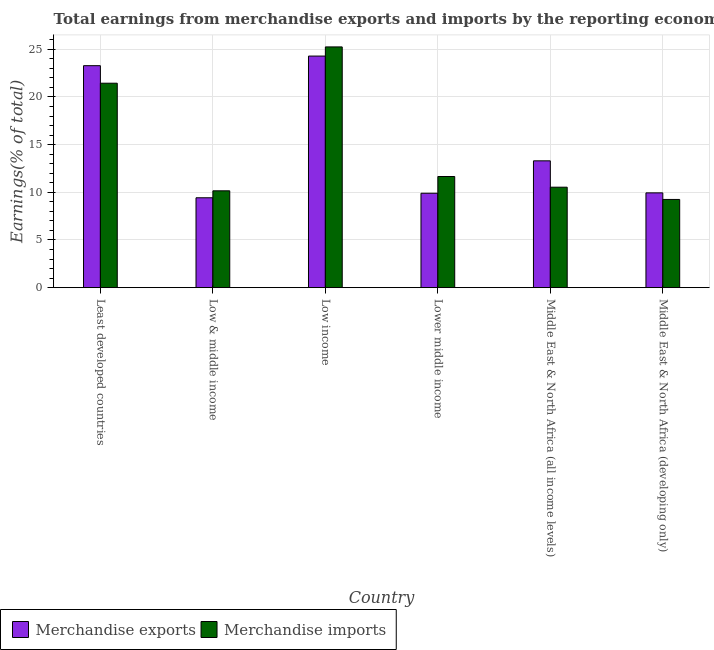Are the number of bars per tick equal to the number of legend labels?
Offer a terse response. Yes. How many bars are there on the 5th tick from the right?
Your answer should be very brief. 2. What is the label of the 1st group of bars from the left?
Make the answer very short. Least developed countries. In how many cases, is the number of bars for a given country not equal to the number of legend labels?
Your answer should be very brief. 0. What is the earnings from merchandise imports in Least developed countries?
Give a very brief answer. 21.44. Across all countries, what is the maximum earnings from merchandise imports?
Provide a short and direct response. 25.25. Across all countries, what is the minimum earnings from merchandise exports?
Your answer should be very brief. 9.43. In which country was the earnings from merchandise exports maximum?
Provide a short and direct response. Low income. What is the total earnings from merchandise exports in the graph?
Provide a short and direct response. 90.14. What is the difference between the earnings from merchandise imports in Lower middle income and that in Middle East & North Africa (developing only)?
Provide a succinct answer. 2.41. What is the difference between the earnings from merchandise exports in Middle East & North Africa (developing only) and the earnings from merchandise imports in Middle East & North Africa (all income levels)?
Keep it short and to the point. -0.6. What is the average earnings from merchandise exports per country?
Provide a succinct answer. 15.02. What is the difference between the earnings from merchandise imports and earnings from merchandise exports in Low & middle income?
Your answer should be compact. 0.73. In how many countries, is the earnings from merchandise imports greater than 21 %?
Provide a succinct answer. 2. What is the ratio of the earnings from merchandise exports in Low & middle income to that in Low income?
Offer a very short reply. 0.39. Is the difference between the earnings from merchandise exports in Low & middle income and Middle East & North Africa (all income levels) greater than the difference between the earnings from merchandise imports in Low & middle income and Middle East & North Africa (all income levels)?
Offer a very short reply. No. What is the difference between the highest and the second highest earnings from merchandise imports?
Ensure brevity in your answer.  3.81. What is the difference between the highest and the lowest earnings from merchandise imports?
Your answer should be very brief. 16. Is the sum of the earnings from merchandise imports in Lower middle income and Middle East & North Africa (all income levels) greater than the maximum earnings from merchandise exports across all countries?
Offer a very short reply. No. How many bars are there?
Your answer should be compact. 12. Are all the bars in the graph horizontal?
Provide a succinct answer. No. Are the values on the major ticks of Y-axis written in scientific E-notation?
Your response must be concise. No. What is the title of the graph?
Ensure brevity in your answer.  Total earnings from merchandise exports and imports by the reporting economy(residual) in 1985. What is the label or title of the Y-axis?
Your answer should be very brief. Earnings(% of total). What is the Earnings(% of total) of Merchandise exports in Least developed countries?
Ensure brevity in your answer.  23.28. What is the Earnings(% of total) of Merchandise imports in Least developed countries?
Make the answer very short. 21.44. What is the Earnings(% of total) in Merchandise exports in Low & middle income?
Your answer should be compact. 9.43. What is the Earnings(% of total) of Merchandise imports in Low & middle income?
Your answer should be compact. 10.16. What is the Earnings(% of total) of Merchandise exports in Low income?
Give a very brief answer. 24.29. What is the Earnings(% of total) in Merchandise imports in Low income?
Offer a terse response. 25.25. What is the Earnings(% of total) of Merchandise exports in Lower middle income?
Keep it short and to the point. 9.9. What is the Earnings(% of total) in Merchandise imports in Lower middle income?
Your response must be concise. 11.66. What is the Earnings(% of total) in Merchandise exports in Middle East & North Africa (all income levels)?
Your answer should be very brief. 13.3. What is the Earnings(% of total) in Merchandise imports in Middle East & North Africa (all income levels)?
Your response must be concise. 10.54. What is the Earnings(% of total) in Merchandise exports in Middle East & North Africa (developing only)?
Make the answer very short. 9.94. What is the Earnings(% of total) in Merchandise imports in Middle East & North Africa (developing only)?
Offer a very short reply. 9.25. Across all countries, what is the maximum Earnings(% of total) in Merchandise exports?
Your answer should be compact. 24.29. Across all countries, what is the maximum Earnings(% of total) of Merchandise imports?
Provide a short and direct response. 25.25. Across all countries, what is the minimum Earnings(% of total) of Merchandise exports?
Provide a succinct answer. 9.43. Across all countries, what is the minimum Earnings(% of total) of Merchandise imports?
Your answer should be very brief. 9.25. What is the total Earnings(% of total) of Merchandise exports in the graph?
Make the answer very short. 90.14. What is the total Earnings(% of total) in Merchandise imports in the graph?
Make the answer very short. 88.29. What is the difference between the Earnings(% of total) in Merchandise exports in Least developed countries and that in Low & middle income?
Ensure brevity in your answer.  13.85. What is the difference between the Earnings(% of total) of Merchandise imports in Least developed countries and that in Low & middle income?
Offer a terse response. 11.28. What is the difference between the Earnings(% of total) of Merchandise exports in Least developed countries and that in Low income?
Offer a terse response. -1.01. What is the difference between the Earnings(% of total) in Merchandise imports in Least developed countries and that in Low income?
Your answer should be very brief. -3.81. What is the difference between the Earnings(% of total) in Merchandise exports in Least developed countries and that in Lower middle income?
Your response must be concise. 13.38. What is the difference between the Earnings(% of total) in Merchandise imports in Least developed countries and that in Lower middle income?
Your answer should be compact. 9.78. What is the difference between the Earnings(% of total) in Merchandise exports in Least developed countries and that in Middle East & North Africa (all income levels)?
Make the answer very short. 9.98. What is the difference between the Earnings(% of total) in Merchandise imports in Least developed countries and that in Middle East & North Africa (all income levels)?
Keep it short and to the point. 10.9. What is the difference between the Earnings(% of total) in Merchandise exports in Least developed countries and that in Middle East & North Africa (developing only)?
Make the answer very short. 13.34. What is the difference between the Earnings(% of total) of Merchandise imports in Least developed countries and that in Middle East & North Africa (developing only)?
Your answer should be very brief. 12.19. What is the difference between the Earnings(% of total) of Merchandise exports in Low & middle income and that in Low income?
Give a very brief answer. -14.86. What is the difference between the Earnings(% of total) of Merchandise imports in Low & middle income and that in Low income?
Ensure brevity in your answer.  -15.09. What is the difference between the Earnings(% of total) in Merchandise exports in Low & middle income and that in Lower middle income?
Your response must be concise. -0.48. What is the difference between the Earnings(% of total) of Merchandise imports in Low & middle income and that in Lower middle income?
Give a very brief answer. -1.5. What is the difference between the Earnings(% of total) of Merchandise exports in Low & middle income and that in Middle East & North Africa (all income levels)?
Give a very brief answer. -3.87. What is the difference between the Earnings(% of total) in Merchandise imports in Low & middle income and that in Middle East & North Africa (all income levels)?
Your answer should be compact. -0.38. What is the difference between the Earnings(% of total) in Merchandise exports in Low & middle income and that in Middle East & North Africa (developing only)?
Give a very brief answer. -0.51. What is the difference between the Earnings(% of total) in Merchandise imports in Low & middle income and that in Middle East & North Africa (developing only)?
Make the answer very short. 0.91. What is the difference between the Earnings(% of total) in Merchandise exports in Low income and that in Lower middle income?
Provide a succinct answer. 14.38. What is the difference between the Earnings(% of total) in Merchandise imports in Low income and that in Lower middle income?
Your response must be concise. 13.59. What is the difference between the Earnings(% of total) of Merchandise exports in Low income and that in Middle East & North Africa (all income levels)?
Your response must be concise. 10.99. What is the difference between the Earnings(% of total) in Merchandise imports in Low income and that in Middle East & North Africa (all income levels)?
Offer a terse response. 14.71. What is the difference between the Earnings(% of total) of Merchandise exports in Low income and that in Middle East & North Africa (developing only)?
Provide a short and direct response. 14.35. What is the difference between the Earnings(% of total) of Merchandise imports in Low income and that in Middle East & North Africa (developing only)?
Ensure brevity in your answer.  16. What is the difference between the Earnings(% of total) in Merchandise exports in Lower middle income and that in Middle East & North Africa (all income levels)?
Offer a very short reply. -3.4. What is the difference between the Earnings(% of total) in Merchandise imports in Lower middle income and that in Middle East & North Africa (all income levels)?
Provide a short and direct response. 1.12. What is the difference between the Earnings(% of total) in Merchandise exports in Lower middle income and that in Middle East & North Africa (developing only)?
Give a very brief answer. -0.04. What is the difference between the Earnings(% of total) in Merchandise imports in Lower middle income and that in Middle East & North Africa (developing only)?
Offer a very short reply. 2.41. What is the difference between the Earnings(% of total) in Merchandise exports in Middle East & North Africa (all income levels) and that in Middle East & North Africa (developing only)?
Provide a short and direct response. 3.36. What is the difference between the Earnings(% of total) in Merchandise imports in Middle East & North Africa (all income levels) and that in Middle East & North Africa (developing only)?
Your answer should be compact. 1.29. What is the difference between the Earnings(% of total) in Merchandise exports in Least developed countries and the Earnings(% of total) in Merchandise imports in Low & middle income?
Give a very brief answer. 13.12. What is the difference between the Earnings(% of total) in Merchandise exports in Least developed countries and the Earnings(% of total) in Merchandise imports in Low income?
Ensure brevity in your answer.  -1.97. What is the difference between the Earnings(% of total) of Merchandise exports in Least developed countries and the Earnings(% of total) of Merchandise imports in Lower middle income?
Give a very brief answer. 11.62. What is the difference between the Earnings(% of total) of Merchandise exports in Least developed countries and the Earnings(% of total) of Merchandise imports in Middle East & North Africa (all income levels)?
Provide a short and direct response. 12.74. What is the difference between the Earnings(% of total) in Merchandise exports in Least developed countries and the Earnings(% of total) in Merchandise imports in Middle East & North Africa (developing only)?
Give a very brief answer. 14.03. What is the difference between the Earnings(% of total) of Merchandise exports in Low & middle income and the Earnings(% of total) of Merchandise imports in Low income?
Your answer should be compact. -15.82. What is the difference between the Earnings(% of total) of Merchandise exports in Low & middle income and the Earnings(% of total) of Merchandise imports in Lower middle income?
Make the answer very short. -2.23. What is the difference between the Earnings(% of total) of Merchandise exports in Low & middle income and the Earnings(% of total) of Merchandise imports in Middle East & North Africa (all income levels)?
Ensure brevity in your answer.  -1.11. What is the difference between the Earnings(% of total) in Merchandise exports in Low & middle income and the Earnings(% of total) in Merchandise imports in Middle East & North Africa (developing only)?
Offer a very short reply. 0.18. What is the difference between the Earnings(% of total) in Merchandise exports in Low income and the Earnings(% of total) in Merchandise imports in Lower middle income?
Your response must be concise. 12.63. What is the difference between the Earnings(% of total) in Merchandise exports in Low income and the Earnings(% of total) in Merchandise imports in Middle East & North Africa (all income levels)?
Give a very brief answer. 13.75. What is the difference between the Earnings(% of total) of Merchandise exports in Low income and the Earnings(% of total) of Merchandise imports in Middle East & North Africa (developing only)?
Keep it short and to the point. 15.04. What is the difference between the Earnings(% of total) of Merchandise exports in Lower middle income and the Earnings(% of total) of Merchandise imports in Middle East & North Africa (all income levels)?
Give a very brief answer. -0.63. What is the difference between the Earnings(% of total) in Merchandise exports in Lower middle income and the Earnings(% of total) in Merchandise imports in Middle East & North Africa (developing only)?
Your answer should be compact. 0.65. What is the difference between the Earnings(% of total) of Merchandise exports in Middle East & North Africa (all income levels) and the Earnings(% of total) of Merchandise imports in Middle East & North Africa (developing only)?
Provide a short and direct response. 4.05. What is the average Earnings(% of total) in Merchandise exports per country?
Your response must be concise. 15.02. What is the average Earnings(% of total) of Merchandise imports per country?
Ensure brevity in your answer.  14.71. What is the difference between the Earnings(% of total) in Merchandise exports and Earnings(% of total) in Merchandise imports in Least developed countries?
Give a very brief answer. 1.84. What is the difference between the Earnings(% of total) in Merchandise exports and Earnings(% of total) in Merchandise imports in Low & middle income?
Your response must be concise. -0.73. What is the difference between the Earnings(% of total) of Merchandise exports and Earnings(% of total) of Merchandise imports in Low income?
Provide a short and direct response. -0.96. What is the difference between the Earnings(% of total) of Merchandise exports and Earnings(% of total) of Merchandise imports in Lower middle income?
Offer a very short reply. -1.75. What is the difference between the Earnings(% of total) of Merchandise exports and Earnings(% of total) of Merchandise imports in Middle East & North Africa (all income levels)?
Make the answer very short. 2.76. What is the difference between the Earnings(% of total) of Merchandise exports and Earnings(% of total) of Merchandise imports in Middle East & North Africa (developing only)?
Offer a very short reply. 0.69. What is the ratio of the Earnings(% of total) of Merchandise exports in Least developed countries to that in Low & middle income?
Provide a succinct answer. 2.47. What is the ratio of the Earnings(% of total) in Merchandise imports in Least developed countries to that in Low & middle income?
Your response must be concise. 2.11. What is the ratio of the Earnings(% of total) of Merchandise exports in Least developed countries to that in Low income?
Ensure brevity in your answer.  0.96. What is the ratio of the Earnings(% of total) of Merchandise imports in Least developed countries to that in Low income?
Keep it short and to the point. 0.85. What is the ratio of the Earnings(% of total) in Merchandise exports in Least developed countries to that in Lower middle income?
Give a very brief answer. 2.35. What is the ratio of the Earnings(% of total) in Merchandise imports in Least developed countries to that in Lower middle income?
Your response must be concise. 1.84. What is the ratio of the Earnings(% of total) of Merchandise exports in Least developed countries to that in Middle East & North Africa (all income levels)?
Ensure brevity in your answer.  1.75. What is the ratio of the Earnings(% of total) of Merchandise imports in Least developed countries to that in Middle East & North Africa (all income levels)?
Give a very brief answer. 2.03. What is the ratio of the Earnings(% of total) in Merchandise exports in Least developed countries to that in Middle East & North Africa (developing only)?
Your answer should be compact. 2.34. What is the ratio of the Earnings(% of total) in Merchandise imports in Least developed countries to that in Middle East & North Africa (developing only)?
Your answer should be very brief. 2.32. What is the ratio of the Earnings(% of total) of Merchandise exports in Low & middle income to that in Low income?
Your answer should be very brief. 0.39. What is the ratio of the Earnings(% of total) of Merchandise imports in Low & middle income to that in Low income?
Provide a succinct answer. 0.4. What is the ratio of the Earnings(% of total) in Merchandise exports in Low & middle income to that in Lower middle income?
Keep it short and to the point. 0.95. What is the ratio of the Earnings(% of total) in Merchandise imports in Low & middle income to that in Lower middle income?
Ensure brevity in your answer.  0.87. What is the ratio of the Earnings(% of total) of Merchandise exports in Low & middle income to that in Middle East & North Africa (all income levels)?
Offer a very short reply. 0.71. What is the ratio of the Earnings(% of total) in Merchandise imports in Low & middle income to that in Middle East & North Africa (all income levels)?
Your answer should be very brief. 0.96. What is the ratio of the Earnings(% of total) of Merchandise exports in Low & middle income to that in Middle East & North Africa (developing only)?
Your answer should be compact. 0.95. What is the ratio of the Earnings(% of total) of Merchandise imports in Low & middle income to that in Middle East & North Africa (developing only)?
Ensure brevity in your answer.  1.1. What is the ratio of the Earnings(% of total) of Merchandise exports in Low income to that in Lower middle income?
Provide a succinct answer. 2.45. What is the ratio of the Earnings(% of total) in Merchandise imports in Low income to that in Lower middle income?
Make the answer very short. 2.17. What is the ratio of the Earnings(% of total) of Merchandise exports in Low income to that in Middle East & North Africa (all income levels)?
Offer a terse response. 1.83. What is the ratio of the Earnings(% of total) of Merchandise imports in Low income to that in Middle East & North Africa (all income levels)?
Keep it short and to the point. 2.4. What is the ratio of the Earnings(% of total) in Merchandise exports in Low income to that in Middle East & North Africa (developing only)?
Make the answer very short. 2.44. What is the ratio of the Earnings(% of total) of Merchandise imports in Low income to that in Middle East & North Africa (developing only)?
Make the answer very short. 2.73. What is the ratio of the Earnings(% of total) of Merchandise exports in Lower middle income to that in Middle East & North Africa (all income levels)?
Offer a terse response. 0.74. What is the ratio of the Earnings(% of total) in Merchandise imports in Lower middle income to that in Middle East & North Africa (all income levels)?
Your response must be concise. 1.11. What is the ratio of the Earnings(% of total) in Merchandise imports in Lower middle income to that in Middle East & North Africa (developing only)?
Give a very brief answer. 1.26. What is the ratio of the Earnings(% of total) of Merchandise exports in Middle East & North Africa (all income levels) to that in Middle East & North Africa (developing only)?
Keep it short and to the point. 1.34. What is the ratio of the Earnings(% of total) in Merchandise imports in Middle East & North Africa (all income levels) to that in Middle East & North Africa (developing only)?
Offer a terse response. 1.14. What is the difference between the highest and the second highest Earnings(% of total) in Merchandise imports?
Keep it short and to the point. 3.81. What is the difference between the highest and the lowest Earnings(% of total) in Merchandise exports?
Your answer should be very brief. 14.86. What is the difference between the highest and the lowest Earnings(% of total) of Merchandise imports?
Your response must be concise. 16. 